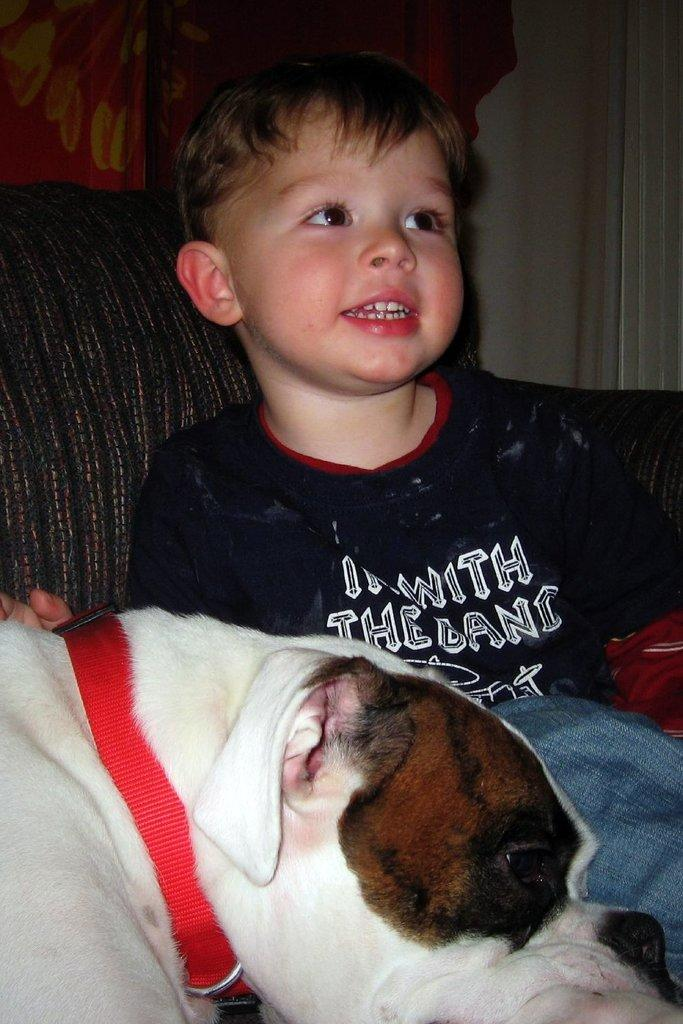Who or what can be seen in the image? There is a person and a dog in the image. Can you describe the person in the image? Unfortunately, the provided facts do not give any details about the person's appearance or clothing. How is the dog positioned in the image? The facts do not specify the dog's position or actions in the image. What type of juice is being poured from the lamp in the image? There is no juice or lamp present in the image. Can you describe the person's reaction to the dog jumping in the image? The facts do not mention any jumping or reactions in the image. 